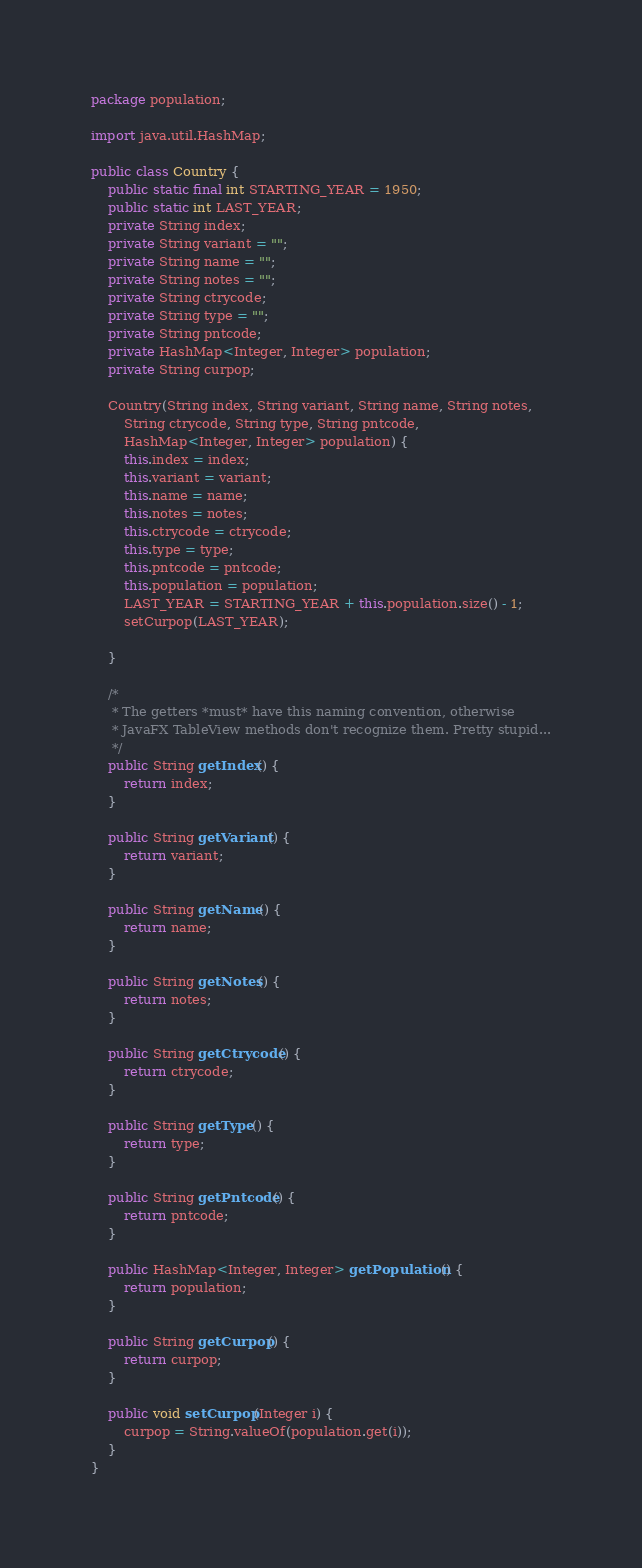Convert code to text. <code><loc_0><loc_0><loc_500><loc_500><_Java_>package population;

import java.util.HashMap;

public class Country {
	public static final int STARTING_YEAR = 1950;
	public static int LAST_YEAR;
	private String index;
	private String variant = "";
	private String name = "";
	private String notes = "";
	private String ctrycode;
	private String type = "";
	private String pntcode;
	private HashMap<Integer, Integer> population;
	private String curpop;

	Country(String index, String variant, String name, String notes,
	    String ctrycode, String type, String pntcode,
	    HashMap<Integer, Integer> population) {
		this.index = index;
		this.variant = variant;
		this.name = name;
		this.notes = notes;
		this.ctrycode = ctrycode;
		this.type = type;
		this.pntcode = pntcode;
		this.population = population;
		LAST_YEAR = STARTING_YEAR + this.population.size() - 1;
		setCurpop(LAST_YEAR);

	}
	
	/* 
	 * The getters *must* have this naming convention, otherwise 
	 * JavaFX TableView methods don't recognize them. Pretty stupid...
	 */
	public String getIndex() {
		return index;
	}
	
	public String getVariant() {
		return variant;
	}
	
	public String getName() {
		return name;
	}
	
	public String getNotes() {
		return notes;
	}
	
	public String getCtrycode() {
		return ctrycode;
	}
	
	public String getType() {
		return type;
	}
	
	public String getPntcode() {
		return pntcode;
	}
	
	public HashMap<Integer, Integer> getPopulation() {
		return population;
	}
	
	public String getCurpop() {
		return curpop;
	}
	
	public void setCurpop(Integer i) {
		curpop = String.valueOf(population.get(i));
	}
}
</code> 